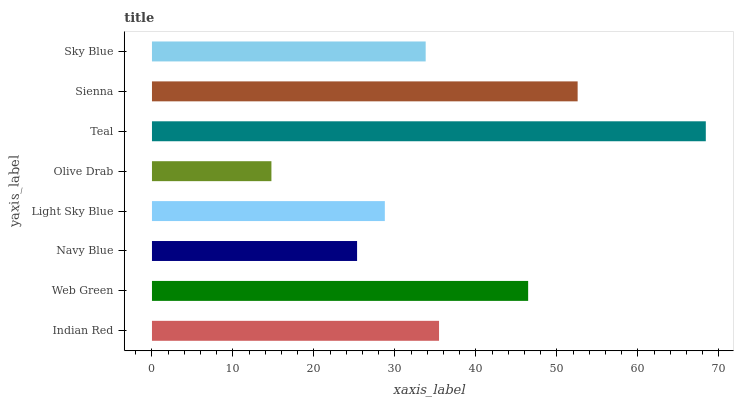Is Olive Drab the minimum?
Answer yes or no. Yes. Is Teal the maximum?
Answer yes or no. Yes. Is Web Green the minimum?
Answer yes or no. No. Is Web Green the maximum?
Answer yes or no. No. Is Web Green greater than Indian Red?
Answer yes or no. Yes. Is Indian Red less than Web Green?
Answer yes or no. Yes. Is Indian Red greater than Web Green?
Answer yes or no. No. Is Web Green less than Indian Red?
Answer yes or no. No. Is Indian Red the high median?
Answer yes or no. Yes. Is Sky Blue the low median?
Answer yes or no. Yes. Is Teal the high median?
Answer yes or no. No. Is Navy Blue the low median?
Answer yes or no. No. 